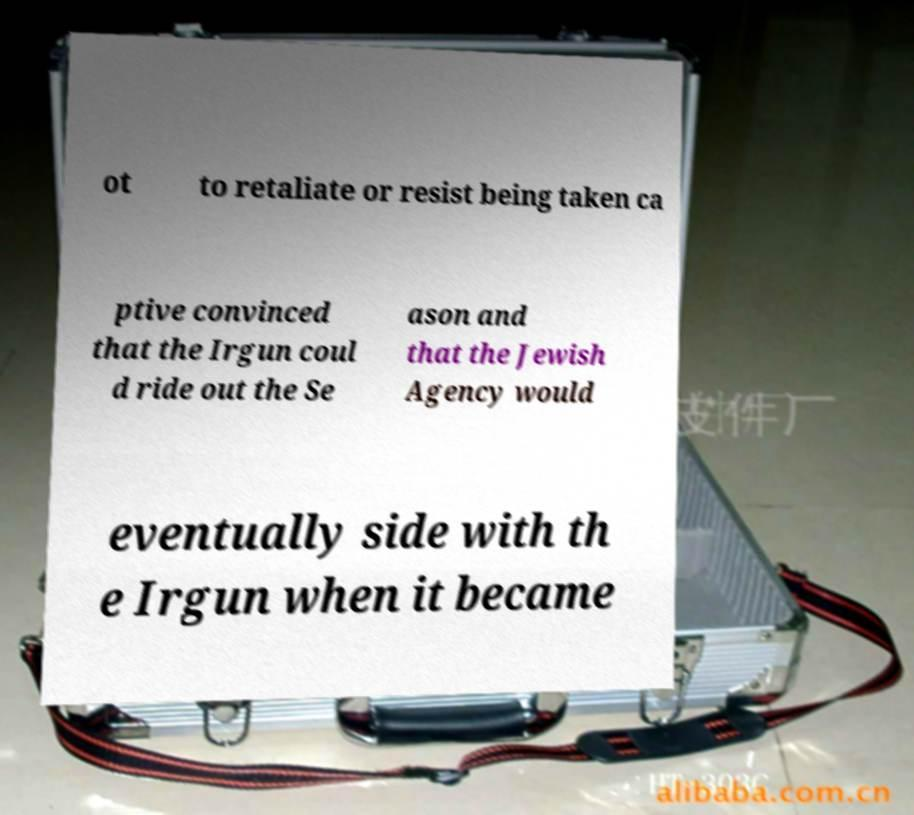I need the written content from this picture converted into text. Can you do that? ot to retaliate or resist being taken ca ptive convinced that the Irgun coul d ride out the Se ason and that the Jewish Agency would eventually side with th e Irgun when it became 